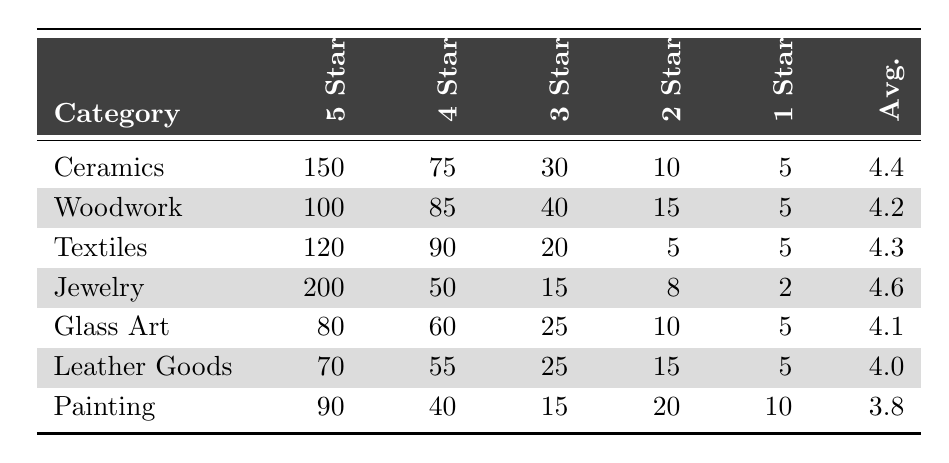What is the average rating for the Jewelry category? The table shows that the average rating for the Jewelry category is listed as 4.6.
Answer: 4.6 Which craft category received the highest number of 5-star ratings? The Jewelry category received the highest number of 5-star ratings, with a total of 200.
Answer: Jewelry What is the total number of ratings received for the Textiles category? To find the total ratings for Textiles, we add the individual ratings: 120 (5-star) + 90 (4-star) + 20 (3-star) + 5 (2-star) + 5 (1-star) = 330.
Answer: 330 Is there a craft category that received more than 100 ratings across all categories? Yes, the Jewelry category received 200 + 50 + 15 + 8 + 2 = 275, which is more than 100.
Answer: Yes Which craft category has the lowest average rating? The lowest average rating in the table is for the Painting category, which has an average of 3.8.
Answer: Painting What is the difference in the number of 5-star ratings between Ceramics and Leather Goods? The number of 5-star ratings for Ceramics is 150, and for Leather Goods, it is 70. The difference is 150 - 70 = 80.
Answer: 80 How many total 1-star ratings were received across all categories? To find the total 1-star ratings, we sum up: 5 + 5 + 5 + 2 + 5 + 10 = 32.
Answer: 32 Which craft category has the highest total of 4 and 5-star ratings combined? For the Jewelry category: 200 (5-star) + 50 (4-star) = 250; for Ceramics: 150 + 75 = 225; and for Textiles: 120 + 90 = 210. Jewelry has the highest total at 250.
Answer: Jewelry What proportion of ratings for Glass Art is 3-star or lower? For Glass Art, the 3-star, 2-star, and 1-star ratings total 25 + 10 + 5 = 40. The total ratings are 80 + 60 + 25 + 10 + 5 = 180. The proportion is 40/180 ≈ 0.222 or 22.2%.
Answer: 22.2% Are there more 5-star ratings for Woodwork than for Leather Goods? Woodwork has 100 (5-star) ratings, while Leather Goods has 70. 100 is greater than 70.
Answer: Yes 